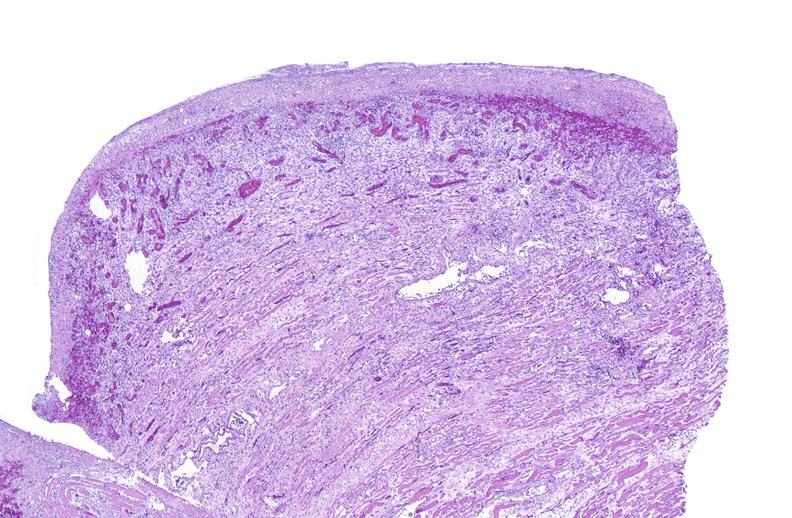what is present?
Answer the question using a single word or phrase. Muscle 